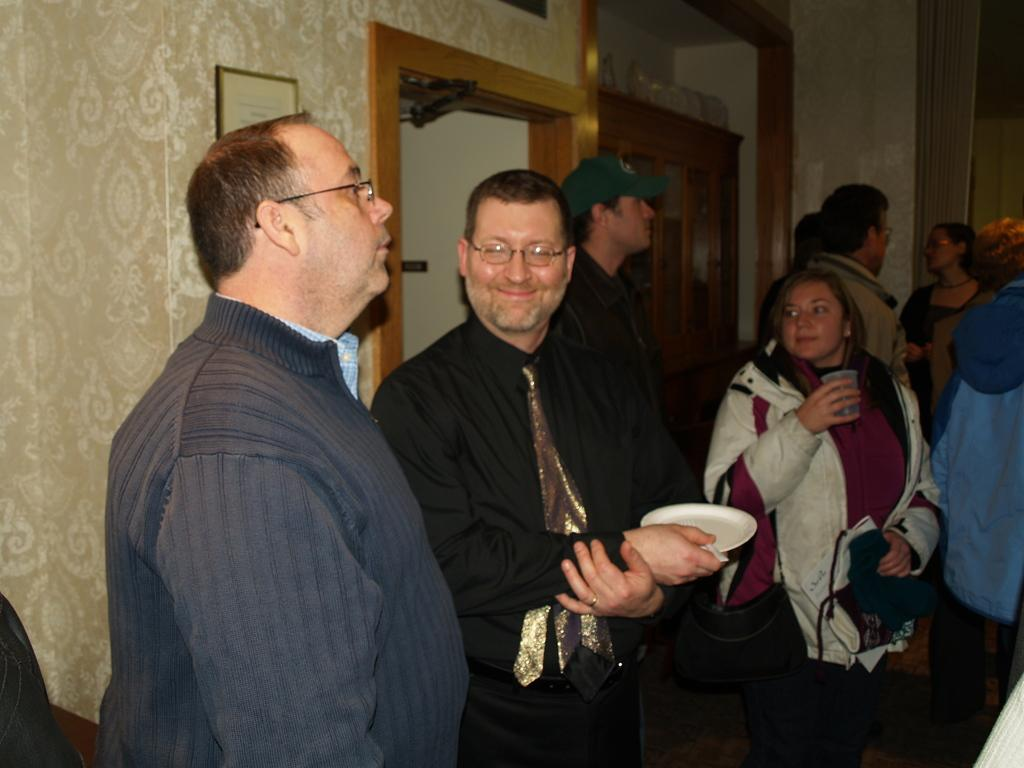What are the people in the image doing? The people in the image are standing and holding plates and glasses. What objects can be seen in the image besides the people? There is a frame, a door, a cupboard, and a wall in the image. How many wheels are visible in the image? There are no wheels visible in the image. What type of show is being performed by the people in the image? There is no indication of a show being performed in the image; the people are simply standing and holding plates and glasses. 